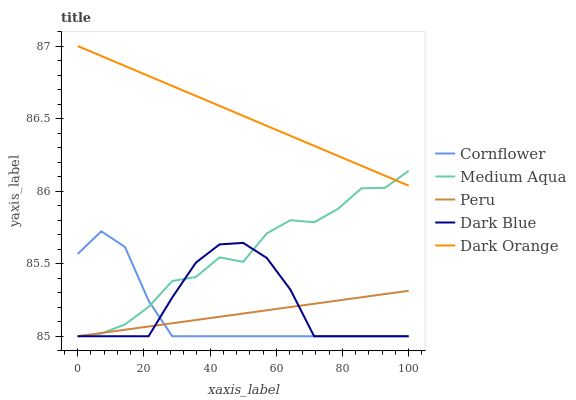Does Cornflower have the minimum area under the curve?
Answer yes or no. Yes. Does Dark Orange have the maximum area under the curve?
Answer yes or no. Yes. Does Medium Aqua have the minimum area under the curve?
Answer yes or no. No. Does Medium Aqua have the maximum area under the curve?
Answer yes or no. No. Is Dark Orange the smoothest?
Answer yes or no. Yes. Is Medium Aqua the roughest?
Answer yes or no. Yes. Is Cornflower the smoothest?
Answer yes or no. No. Is Cornflower the roughest?
Answer yes or no. No. Does Cornflower have the lowest value?
Answer yes or no. Yes. Does Dark Orange have the highest value?
Answer yes or no. Yes. Does Cornflower have the highest value?
Answer yes or no. No. Is Dark Blue less than Dark Orange?
Answer yes or no. Yes. Is Dark Orange greater than Dark Blue?
Answer yes or no. Yes. Does Dark Orange intersect Medium Aqua?
Answer yes or no. Yes. Is Dark Orange less than Medium Aqua?
Answer yes or no. No. Is Dark Orange greater than Medium Aqua?
Answer yes or no. No. Does Dark Blue intersect Dark Orange?
Answer yes or no. No. 